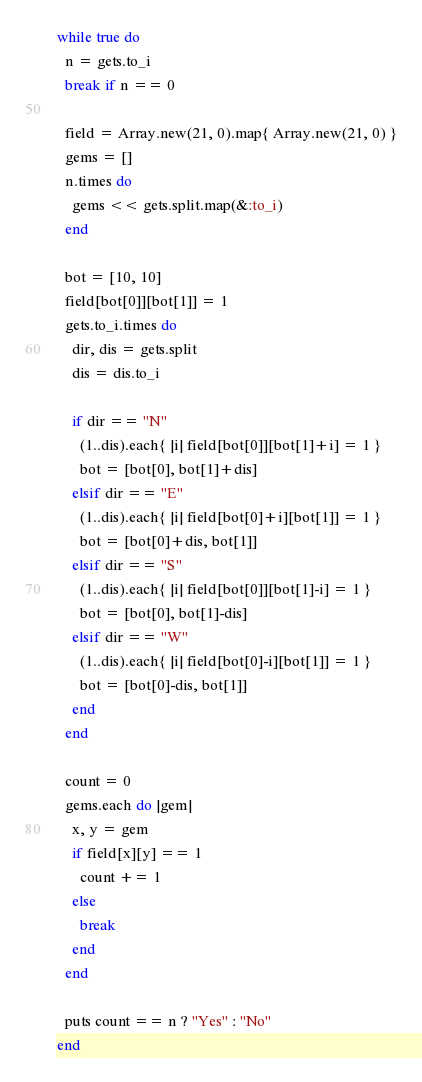Convert code to text. <code><loc_0><loc_0><loc_500><loc_500><_Ruby_>while true do
  n = gets.to_i
  break if n == 0

  field = Array.new(21, 0).map{ Array.new(21, 0) }
  gems = []
  n.times do
    gems << gets.split.map(&:to_i)
  end

  bot = [10, 10]
  field[bot[0]][bot[1]] = 1
  gets.to_i.times do
    dir, dis = gets.split
    dis = dis.to_i

    if dir == "N"
      (1..dis).each{ |i| field[bot[0]][bot[1]+i] = 1 }
      bot = [bot[0], bot[1]+dis]
    elsif dir == "E"
      (1..dis).each{ |i| field[bot[0]+i][bot[1]] = 1 }
      bot = [bot[0]+dis, bot[1]]
    elsif dir == "S"
      (1..dis).each{ |i| field[bot[0]][bot[1]-i] = 1 }
      bot = [bot[0], bot[1]-dis]
    elsif dir == "W"
      (1..dis).each{ |i| field[bot[0]-i][bot[1]] = 1 }
      bot = [bot[0]-dis, bot[1]]
    end
  end

  count = 0
  gems.each do |gem|
    x, y = gem
    if field[x][y] == 1
      count += 1
    else
      break
    end
  end

  puts count == n ? "Yes" : "No"
end</code> 